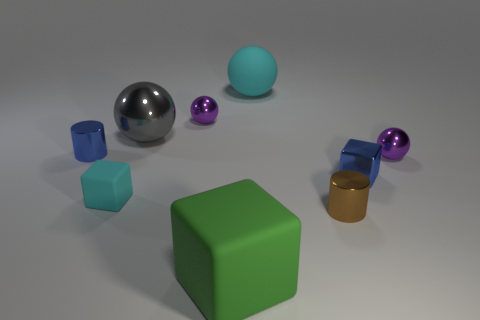Does the small rubber thing have the same color as the big matte sphere?
Offer a very short reply. Yes. There is a object that is the same color as the shiny cube; what material is it?
Give a very brief answer. Metal. Are there any green rubber objects to the right of the blue metal block?
Make the answer very short. No. What material is the large thing that is to the left of the cyan matte sphere and behind the blue cylinder?
Offer a terse response. Metal. Is the large cyan object that is to the right of the gray metallic sphere made of the same material as the large gray ball?
Offer a terse response. No. What material is the big gray object?
Offer a terse response. Metal. There is a rubber cube to the left of the green block; what is its size?
Provide a succinct answer. Small. Is there anything else that has the same color as the big rubber cube?
Your answer should be very brief. No. Is there a shiny object to the left of the rubber ball that is behind the small shiny object to the right of the small blue block?
Your answer should be compact. Yes. There is a metal cylinder behind the tiny blue block; is it the same color as the small shiny cube?
Make the answer very short. Yes. 